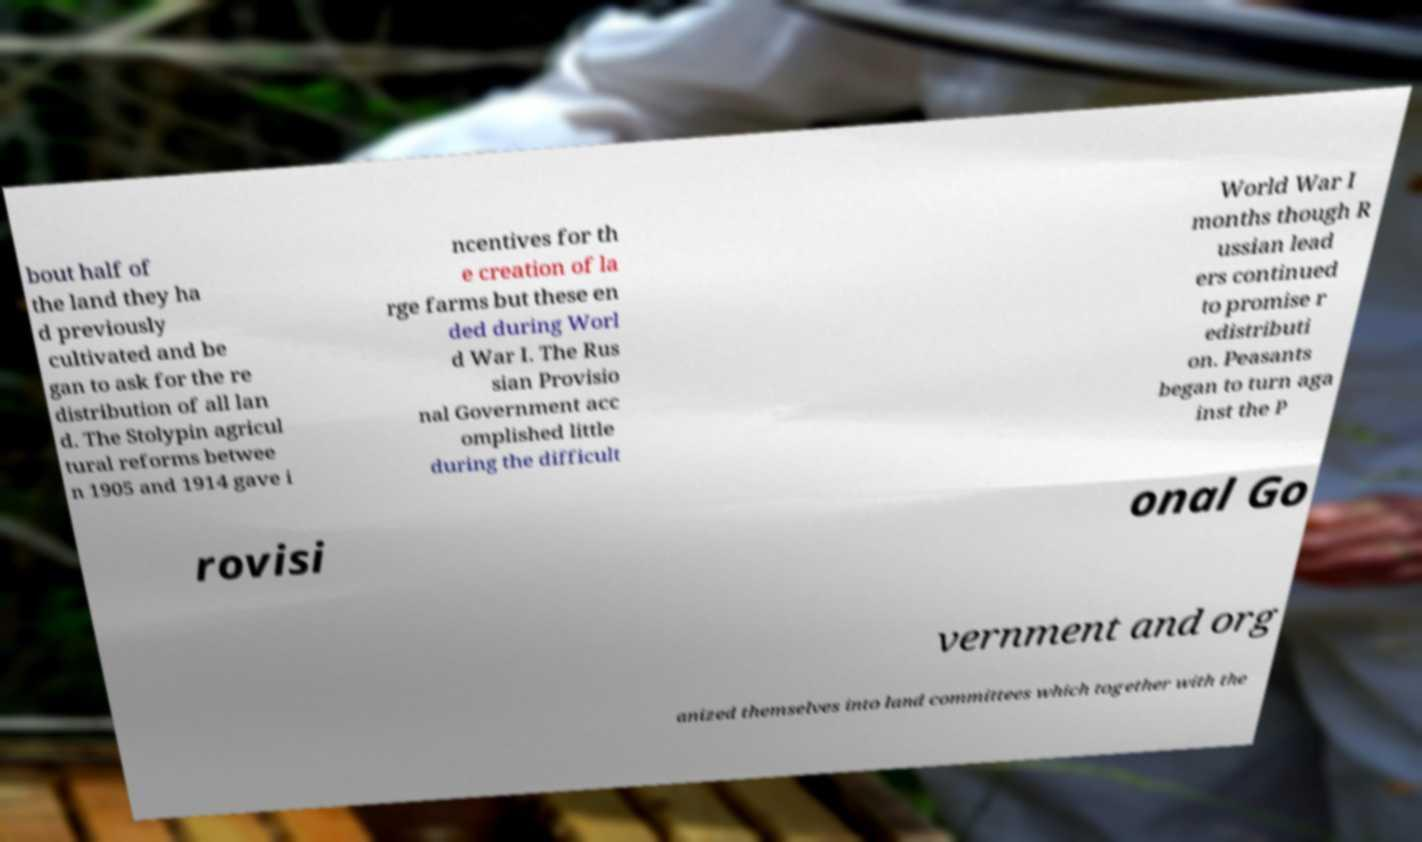I need the written content from this picture converted into text. Can you do that? bout half of the land they ha d previously cultivated and be gan to ask for the re distribution of all lan d. The Stolypin agricul tural reforms betwee n 1905 and 1914 gave i ncentives for th e creation of la rge farms but these en ded during Worl d War I. The Rus sian Provisio nal Government acc omplished little during the difficult World War I months though R ussian lead ers continued to promise r edistributi on. Peasants began to turn aga inst the P rovisi onal Go vernment and org anized themselves into land committees which together with the 